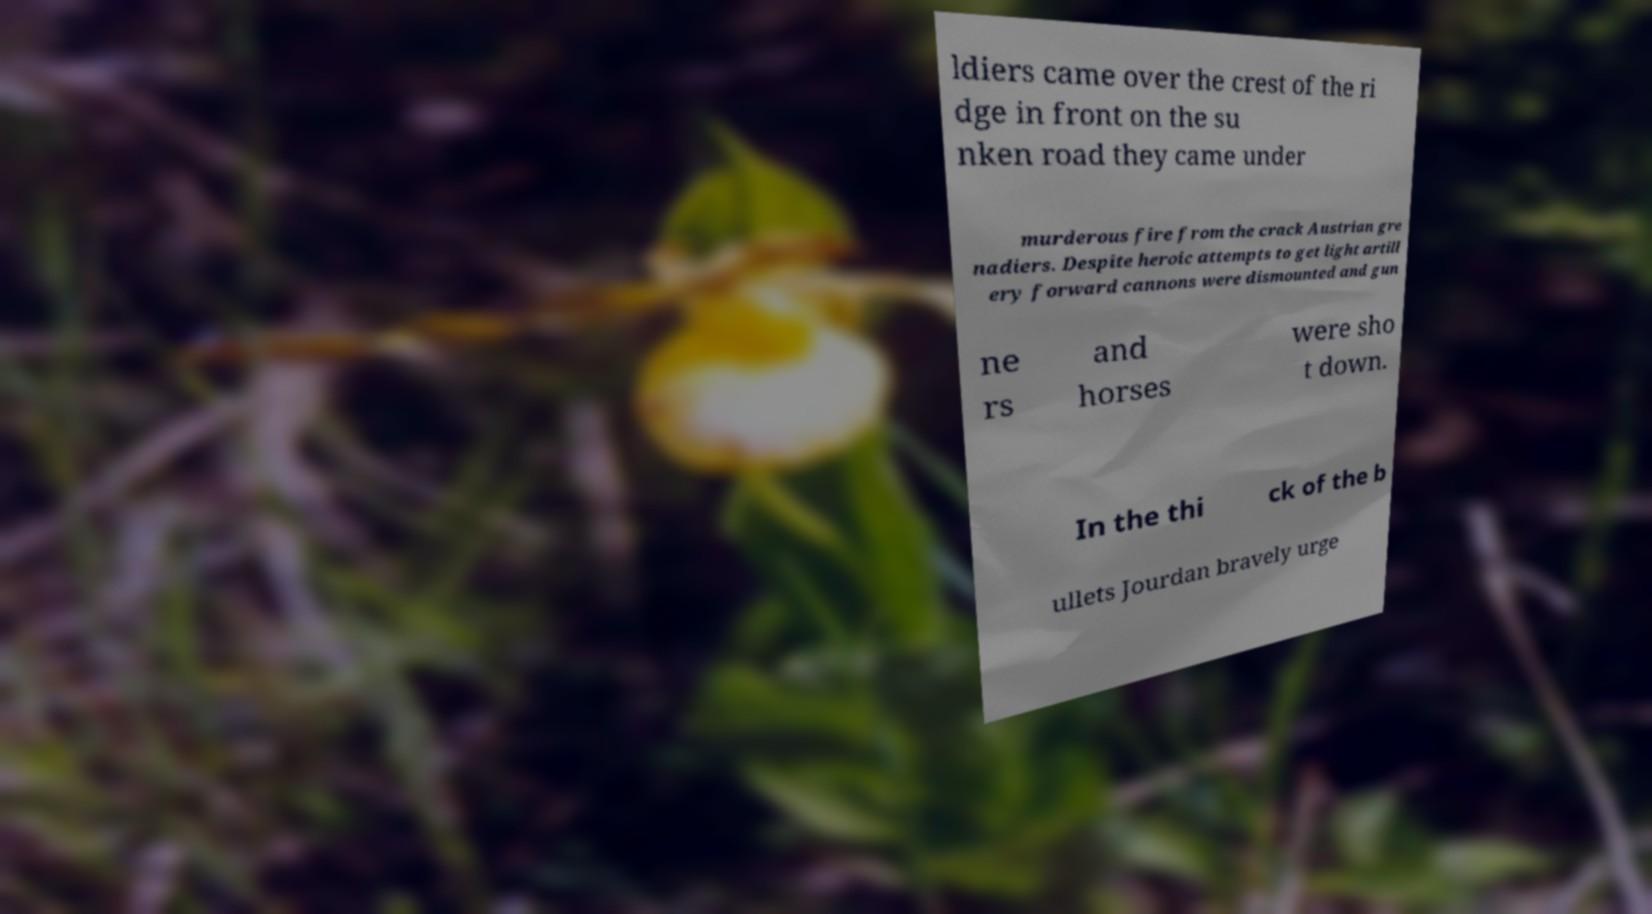Please identify and transcribe the text found in this image. ldiers came over the crest of the ri dge in front on the su nken road they came under murderous fire from the crack Austrian gre nadiers. Despite heroic attempts to get light artill ery forward cannons were dismounted and gun ne rs and horses were sho t down. In the thi ck of the b ullets Jourdan bravely urge 